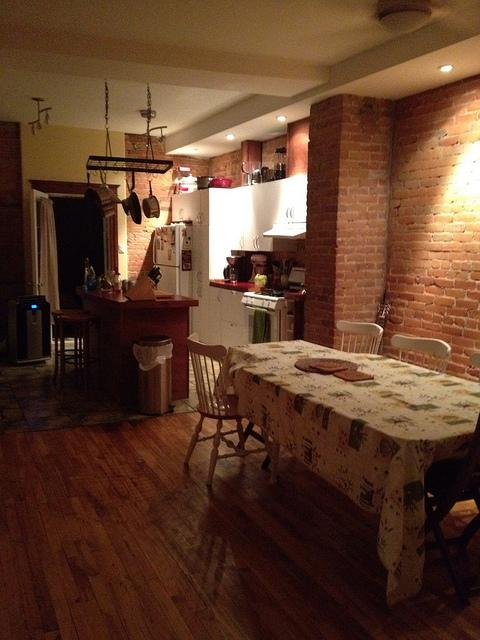What is next to the chair? table 